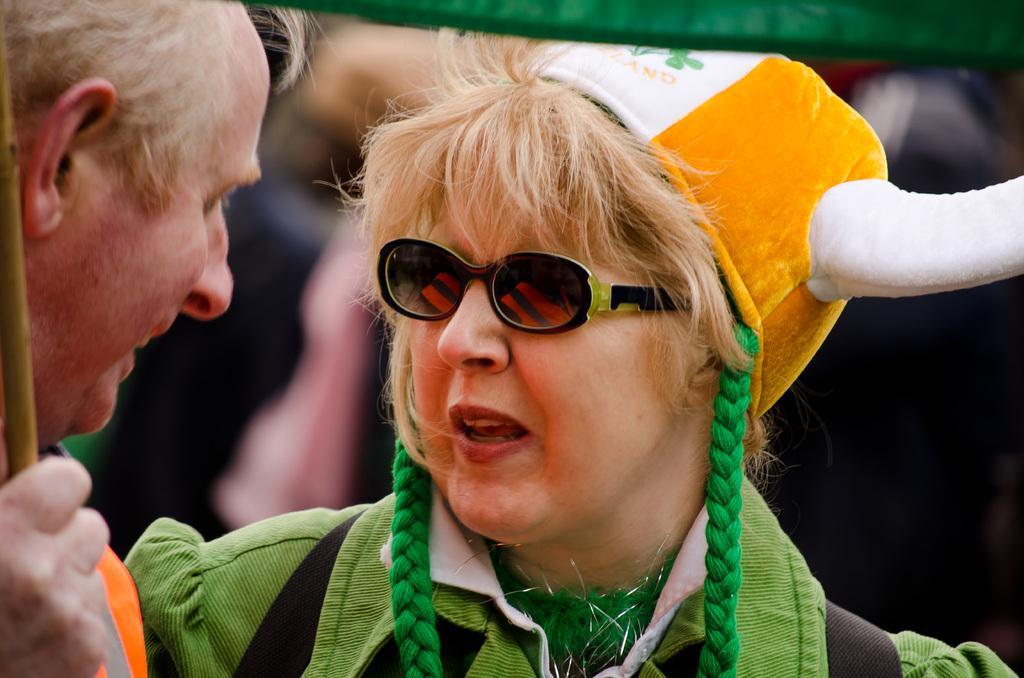How would you summarize this image in a sentence or two? In this picture there is a in the center of the image, she is wearing a costume and there is a man on the left side of the image. 